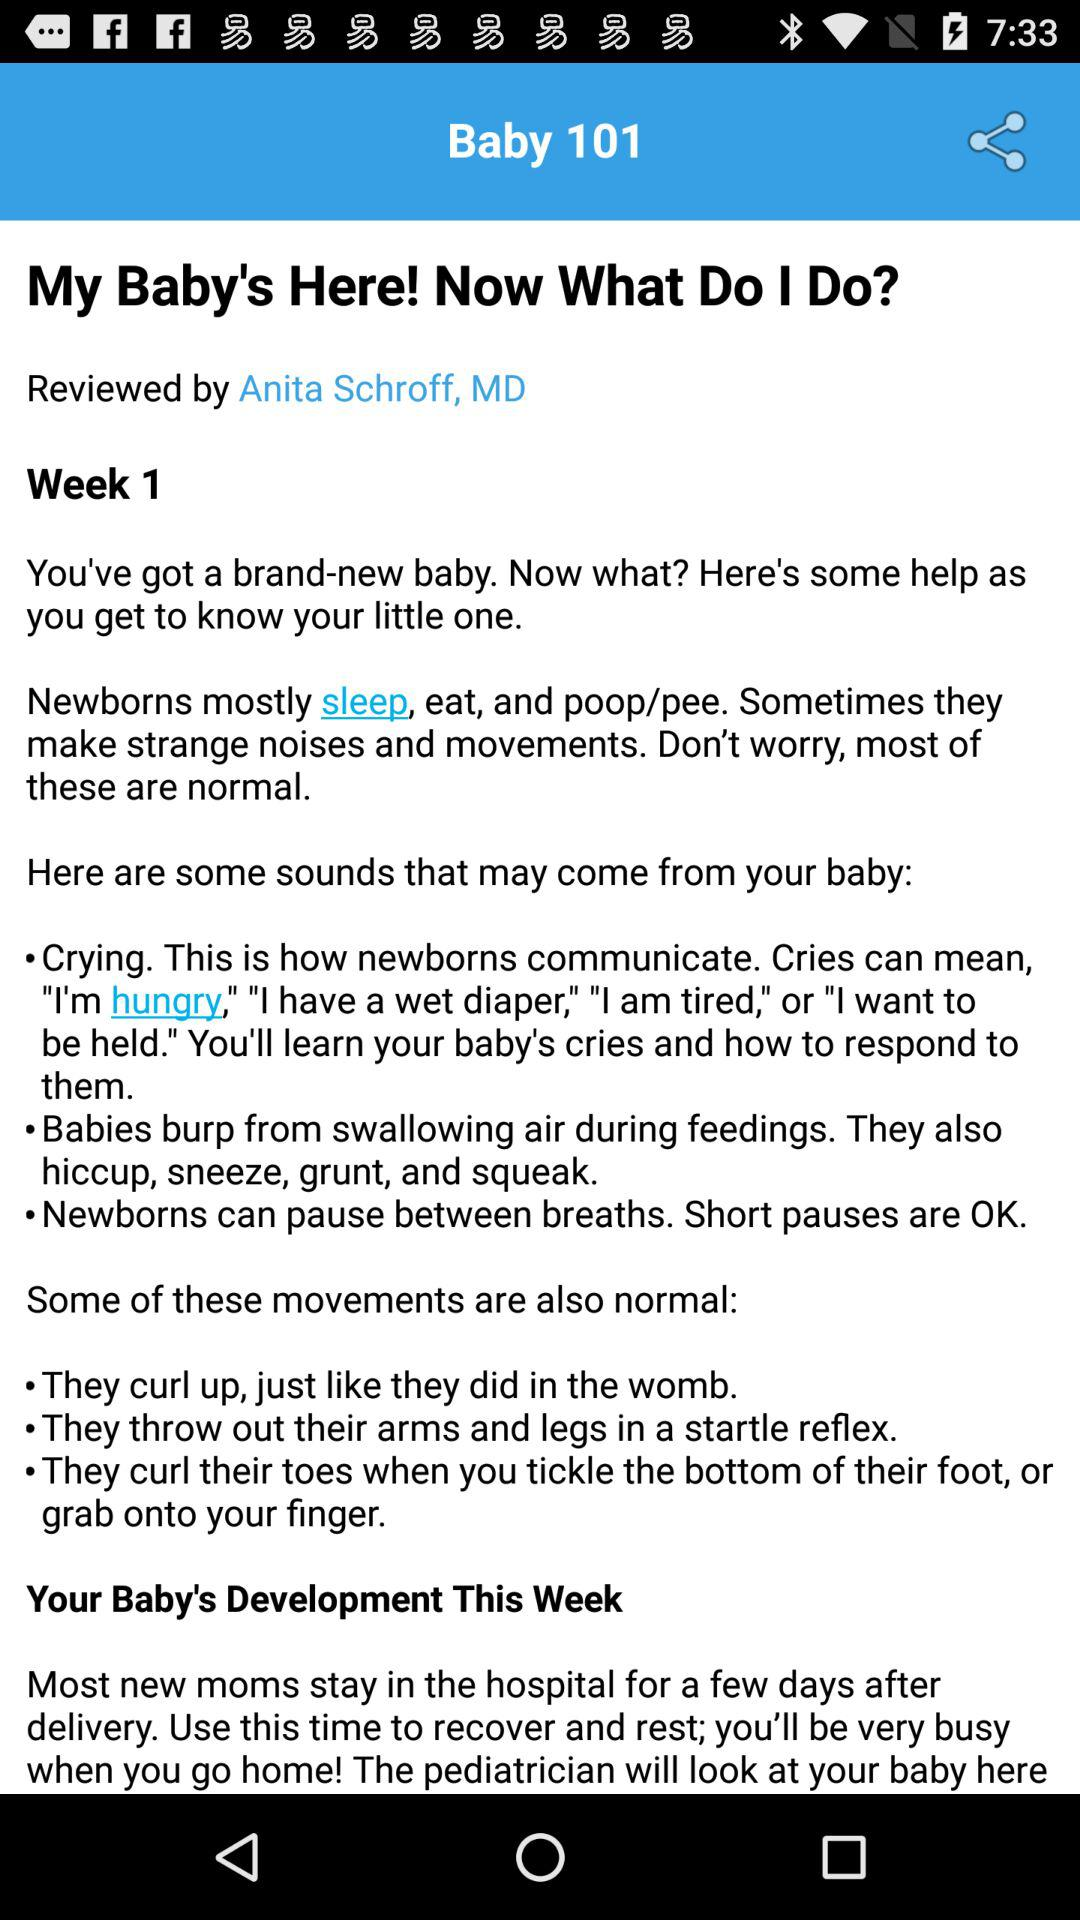Who has reviewed "My Baby's Here! Now What Do I Do?"? "My Baby's Here! Now What Do I Do?" is reviewed by Anita Schroff. 